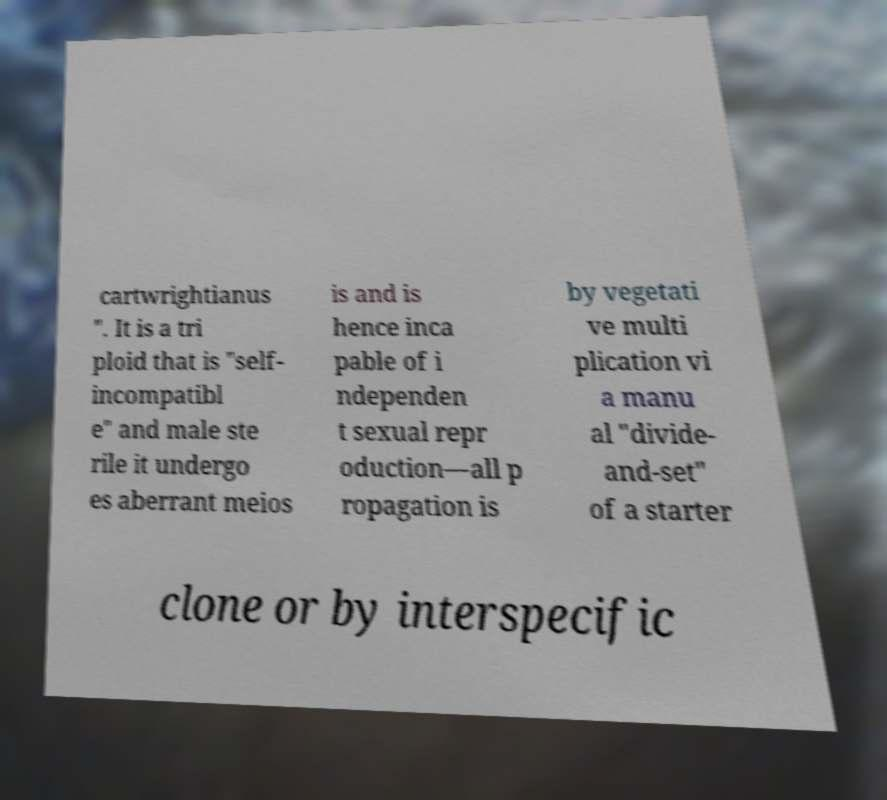For documentation purposes, I need the text within this image transcribed. Could you provide that? cartwrightianus ". It is a tri ploid that is "self- incompatibl e" and male ste rile it undergo es aberrant meios is and is hence inca pable of i ndependen t sexual repr oduction—all p ropagation is by vegetati ve multi plication vi a manu al "divide- and-set" of a starter clone or by interspecific 